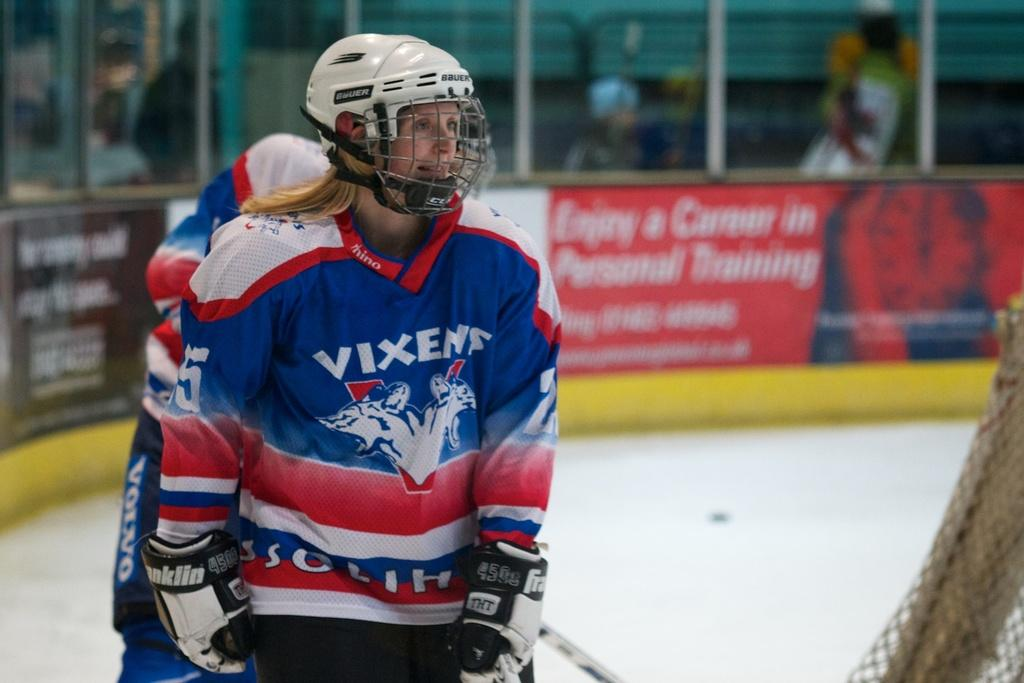Who is present in the image? There is a woman in the image. What is the woman wearing on her head? The woman is wearing a white helmet. What is the woman's facial expression? The woman is smiling. What is the woman's posture in the image? The woman is standing. Can you describe the background of the image? There is another person, hoardings, and other objects in the background of the image. What type of lip balm is the woman applying in the image? There is no lip balm or any indication of the woman applying anything in the image. 